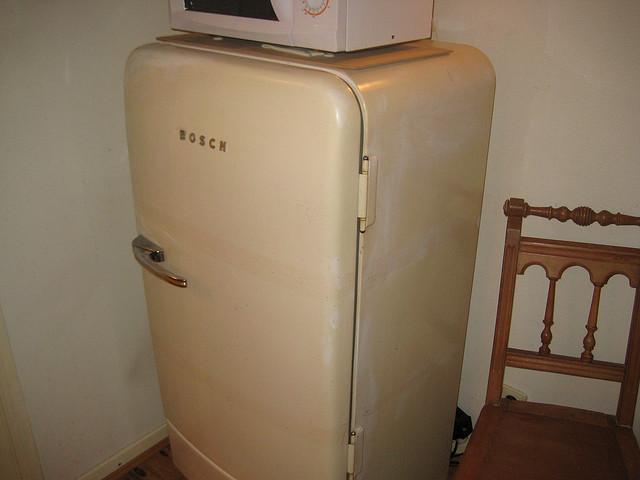What is on top of the fridge?
Short answer required. Microwave. What brand of refrigerator is this?
Short answer required. Bosch. Is this a modern style refrigerator?
Concise answer only. No. What brand is the refrigerator?
Write a very short answer. Bosch. 